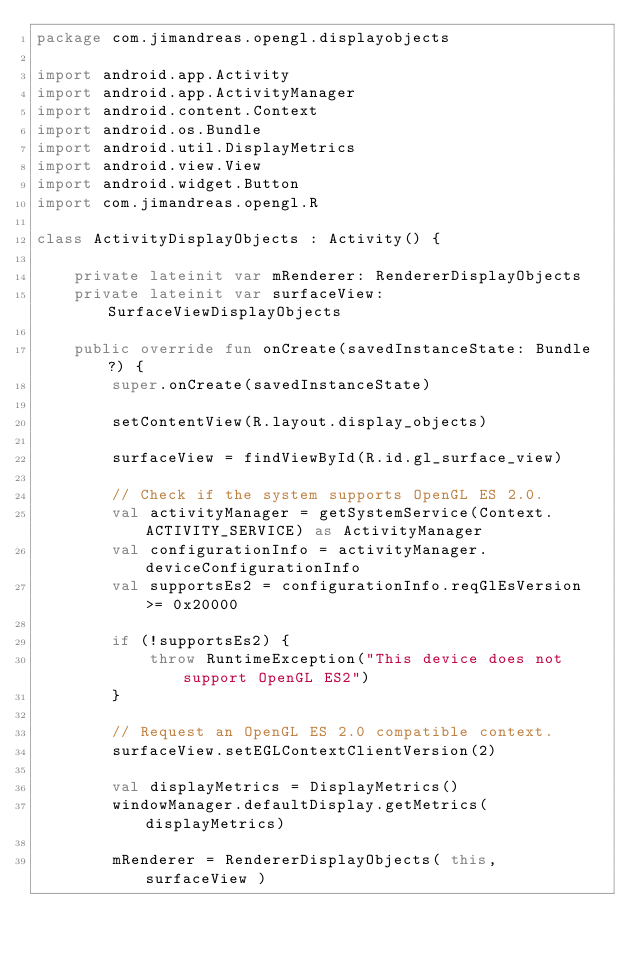Convert code to text. <code><loc_0><loc_0><loc_500><loc_500><_Kotlin_>package com.jimandreas.opengl.displayobjects

import android.app.Activity
import android.app.ActivityManager
import android.content.Context
import android.os.Bundle
import android.util.DisplayMetrics
import android.view.View
import android.widget.Button
import com.jimandreas.opengl.R

class ActivityDisplayObjects : Activity() {

    private lateinit var mRenderer: RendererDisplayObjects
    private lateinit var surfaceView: SurfaceViewDisplayObjects

    public override fun onCreate(savedInstanceState: Bundle?) {
        super.onCreate(savedInstanceState)

        setContentView(R.layout.display_objects)

        surfaceView = findViewById(R.id.gl_surface_view)

        // Check if the system supports OpenGL ES 2.0.
        val activityManager = getSystemService(Context.ACTIVITY_SERVICE) as ActivityManager
        val configurationInfo = activityManager.deviceConfigurationInfo
        val supportsEs2 = configurationInfo.reqGlEsVersion >= 0x20000

        if (!supportsEs2) {
            throw RuntimeException("This device does not support OpenGL ES2")
        }

        // Request an OpenGL ES 2.0 compatible context.
        surfaceView.setEGLContextClientVersion(2)

        val displayMetrics = DisplayMetrics()
        windowManager.defaultDisplay.getMetrics(displayMetrics)

        mRenderer = RendererDisplayObjects( this, surfaceView )</code> 